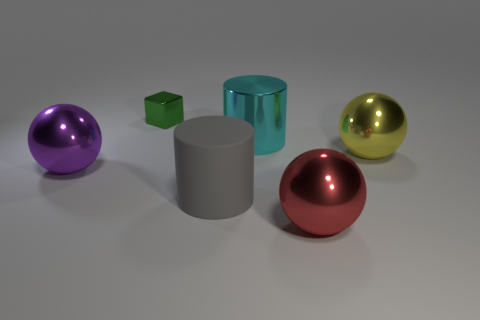There is a thing left of the metal object behind the big metallic cylinder; are there any green metallic objects that are left of it?
Keep it short and to the point. No. Are there any other things that are the same shape as the red object?
Ensure brevity in your answer.  Yes. Is the color of the big cylinder behind the purple sphere the same as the big shiny sphere that is behind the big purple metallic sphere?
Your response must be concise. No. Are there any tiny metal cubes?
Give a very brief answer. Yes. There is a metal thing that is behind the big cylinder that is behind the big metal sphere that is to the left of the tiny green metallic cube; what size is it?
Ensure brevity in your answer.  Small. Is the shape of the large purple metallic object the same as the large object in front of the gray cylinder?
Give a very brief answer. Yes. Are there any big blocks of the same color as the big metallic cylinder?
Your answer should be very brief. No. What number of blocks are red things or small metallic things?
Ensure brevity in your answer.  1. Is there a big red object of the same shape as the yellow object?
Provide a short and direct response. Yes. Are there fewer tiny shiny cubes in front of the small green cube than metallic cylinders?
Provide a short and direct response. Yes. 